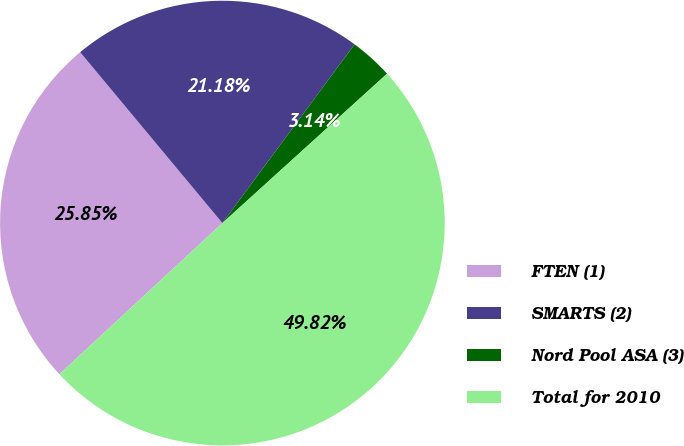Convert chart. <chart><loc_0><loc_0><loc_500><loc_500><pie_chart><fcel>FTEN (1)<fcel>SMARTS (2)<fcel>Nord Pool ASA (3)<fcel>Total for 2010<nl><fcel>25.85%<fcel>21.18%<fcel>3.14%<fcel>49.82%<nl></chart> 